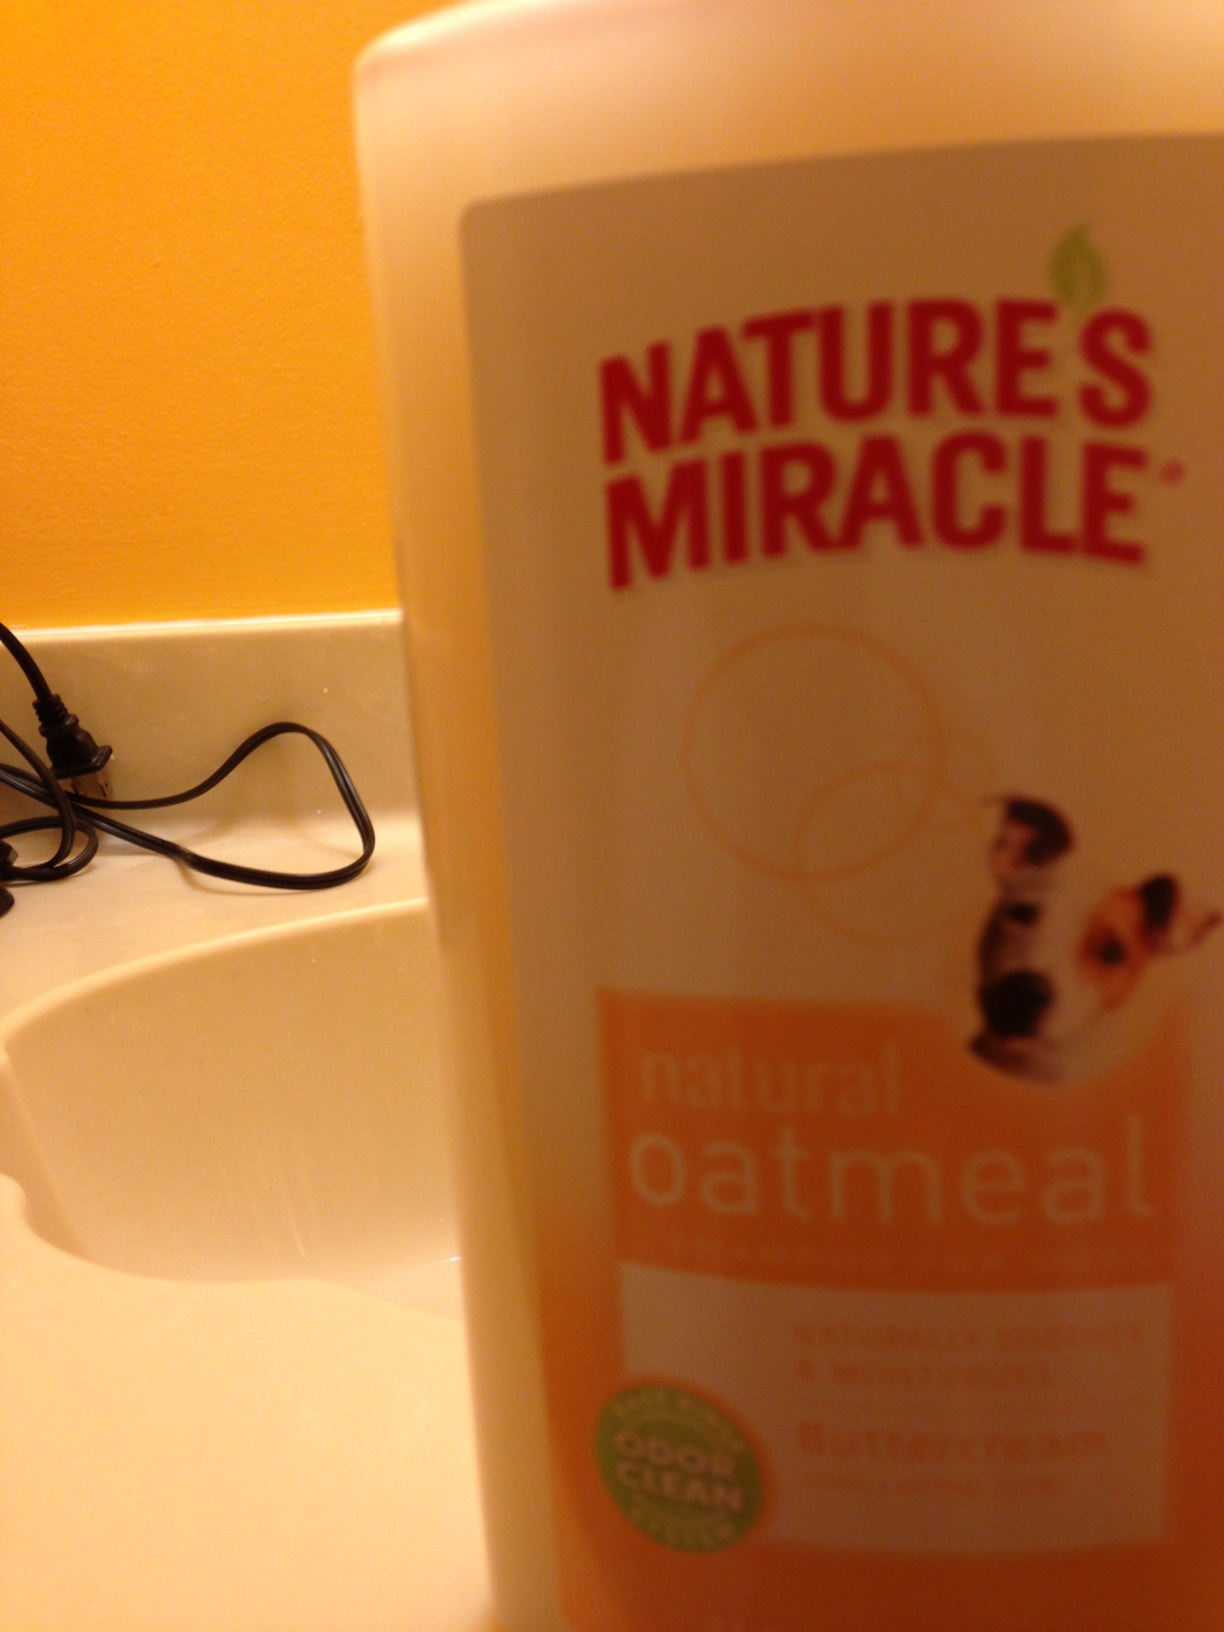Can you tell me more about the features of this product shown in the picture? Certainly! The Nature's Miracle oatmeal shampoo features an advanced odor clean formula designed to neutralize pet odors. It's enriched with oatmeal to help soothe and moisturize your dog's skin, making it an ideal choice for pets with sensitive skin. The oatmeal component provides natural relief from itchiness and may help promote healthy, soft fur. 